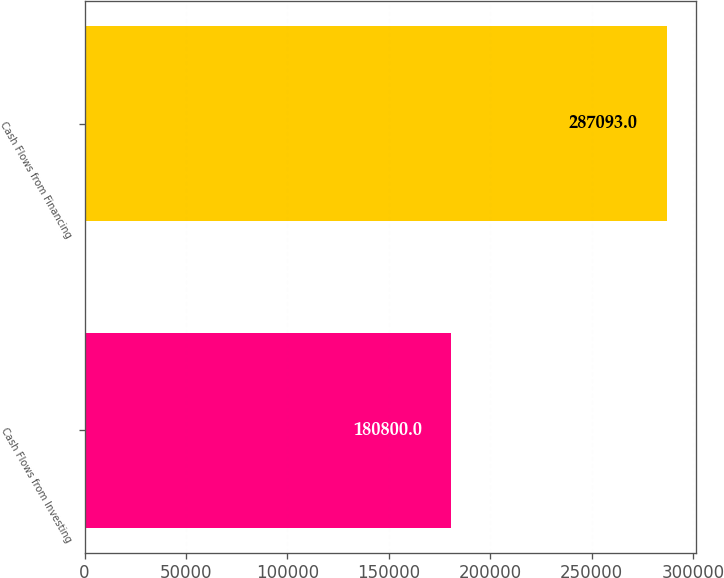Convert chart to OTSL. <chart><loc_0><loc_0><loc_500><loc_500><bar_chart><fcel>Cash Flows from Investing<fcel>Cash Flows from Financing<nl><fcel>180800<fcel>287093<nl></chart> 